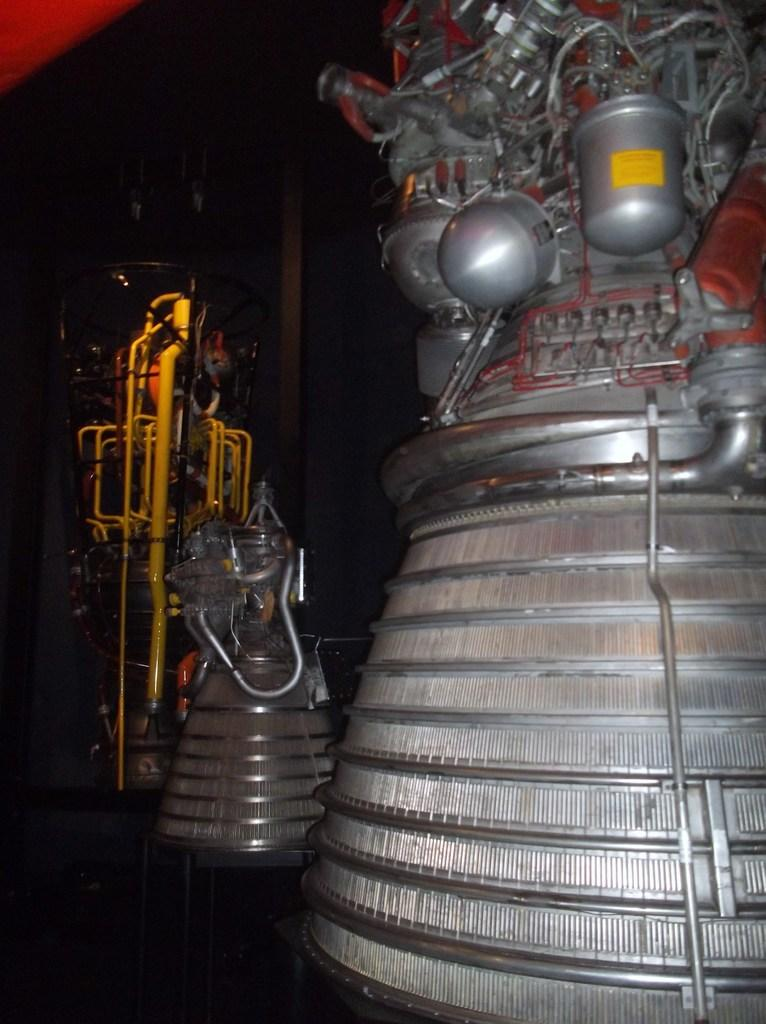What type of objects can be seen in the image? There are metallic objects in the image. Can you describe the color of any object in the image? There is a yellow colored object in the image. What is the background of the image? There is a wall in the image. How does the ink flow on the metallic objects in the image? There is no ink present in the image, so it cannot be determined how it would flow on the metallic objects. 